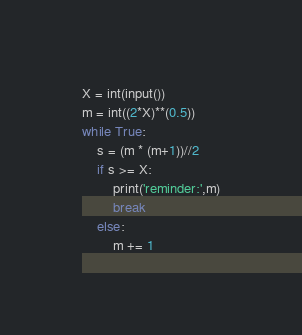Convert code to text. <code><loc_0><loc_0><loc_500><loc_500><_Python_>X = int(input())
m = int((2*X)**(0.5))
while True:
    s = (m * (m+1))//2
    if s >= X:
        print('reminder:',m)
        break
    else:
        m += 1</code> 